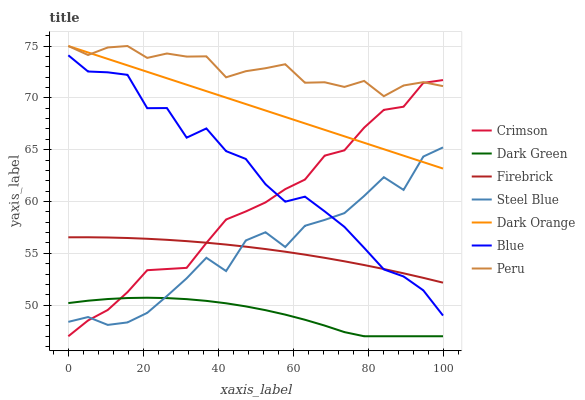Does Dark Orange have the minimum area under the curve?
Answer yes or no. No. Does Dark Orange have the maximum area under the curve?
Answer yes or no. No. Is Firebrick the smoothest?
Answer yes or no. No. Is Firebrick the roughest?
Answer yes or no. No. Does Dark Orange have the lowest value?
Answer yes or no. No. Does Firebrick have the highest value?
Answer yes or no. No. Is Steel Blue less than Peru?
Answer yes or no. Yes. Is Dark Orange greater than Dark Green?
Answer yes or no. Yes. Does Steel Blue intersect Peru?
Answer yes or no. No. 